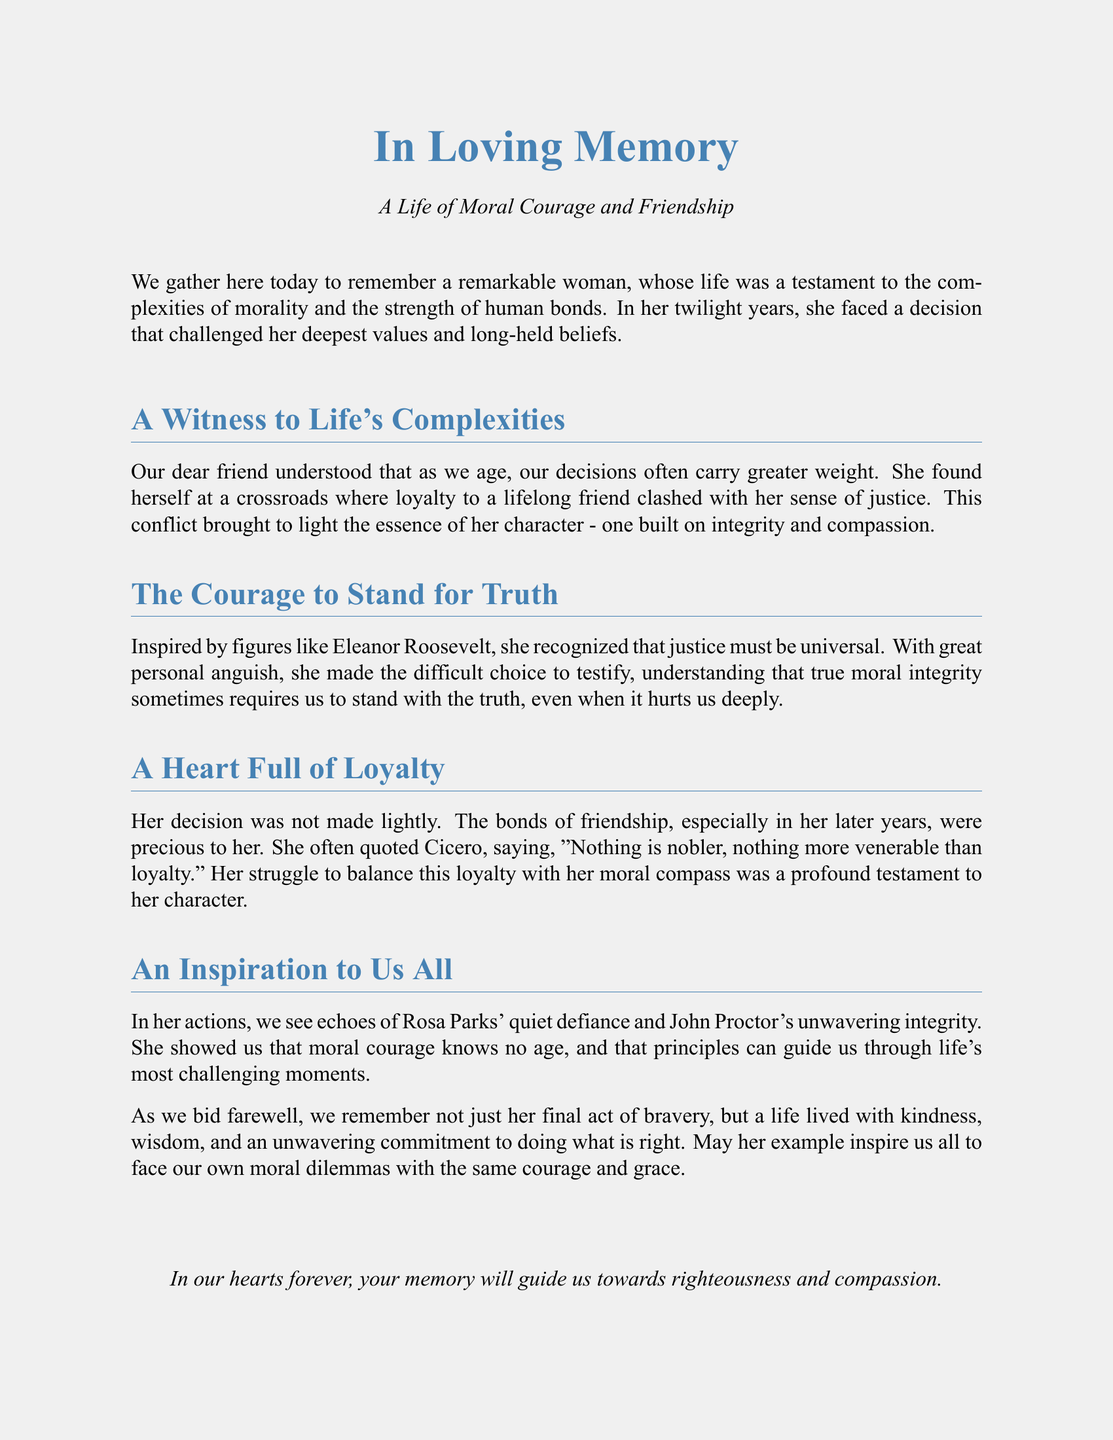What was the focus of the eulogy? The eulogy focuses on the complexities of morality and strength of human bonds in the life of the individual being remembered.
Answer: Morality and friendship Who did the woman look up to for inspiration in her moral choices? The document mentions that she was inspired by figures like Eleanor Roosevelt, who recognized the universality of justice.
Answer: Eleanor Roosevelt What does Cicero's quote in the eulogy emphasize? The quote emphasizes the nobility and reverence of loyalty, which the woman valued greatly despite her moral dilemmas.
Answer: Loyalty Which historical figures are mentioned in the eulogy? The eulogy references Rosa Parks and John Proctor to illustrate the woman's moral courage and integrity.
Answer: Rosa Parks, John Proctor What was the key decision the woman faced later in life? The key decision involved balancing her loyalty to a friend with her obligation to stand for justice.
Answer: Testify What trait does the eulogy attribute to the woman's actions? The actions reflect moral courage, suggesting that integrity and compassion guided her decisions.
Answer: Moral courage What was the woman's view on aging and decision-making? She understood that decisions often carry greater weight as one ages, highlighting the significance of moral choices.
Answer: Greater weight How does the eulogy end regarding the woman's memory? It concludes with a message that her memory will guide others towards righteousness and compassion.
Answer: Righteousness and compassion 